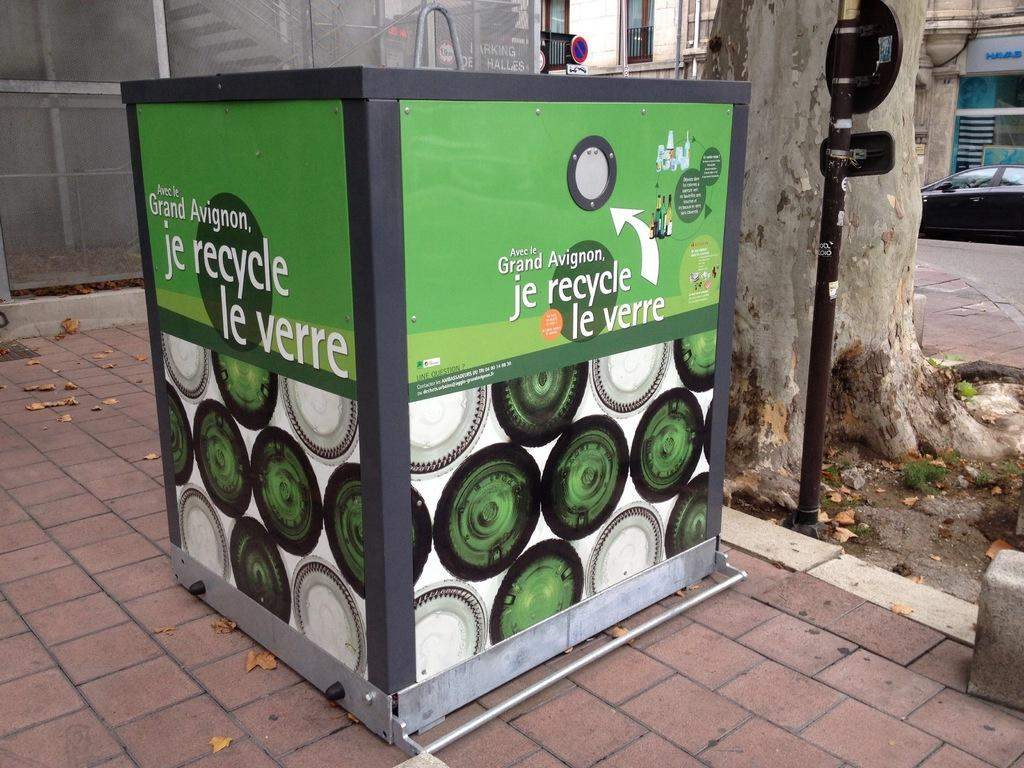What object is placed on the floor in the image? There is a dustbin on the floor in the image. What is located behind the dustbin? There is a board behind the dustbin. What type of vegetation can be seen in the image? There is a tree in the image. What mode of transportation is visible in the image? There is a car in the image. What type of structures can be seen in the background of the image? There are buildings visible in the background of the image. Can you tell me what type of record is playing in the car in the image? There is no record player or music playing mentioned in the image; it only shows a car and other objects. Is there a lake visible in the background of the image? No, there is no lake present in the image; it features a tree, a car, and buildings in the background. 